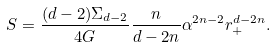<formula> <loc_0><loc_0><loc_500><loc_500>S = \frac { ( d - 2 ) \Sigma _ { d - 2 } } { 4 G } \frac { n } { d - 2 n } \alpha ^ { 2 n - 2 } r _ { + } ^ { d - 2 n } .</formula> 